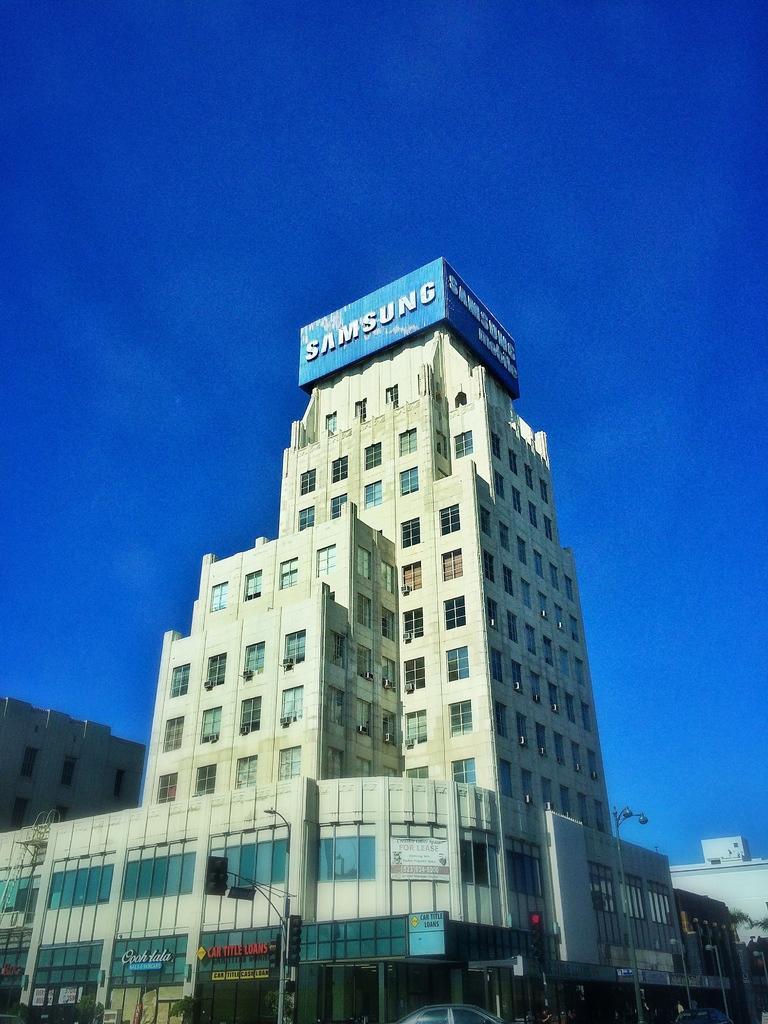In one or two sentences, can you explain what this image depicts? In this image we can see buildings, street poles, street lights, traffic poles, traffic signals, name boards, motor vehicles on the road, trees and sky. 